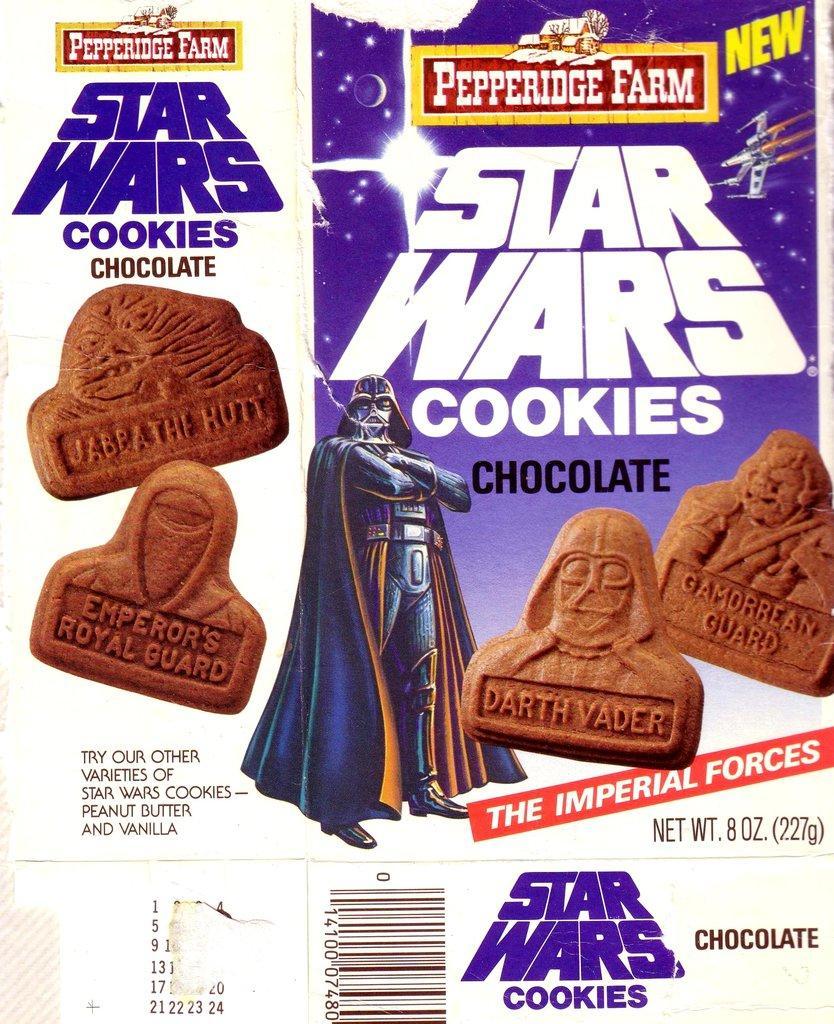Describe this image in one or two sentences. In this image I can see a paper, on the paper I can see few cookies in brown color. 